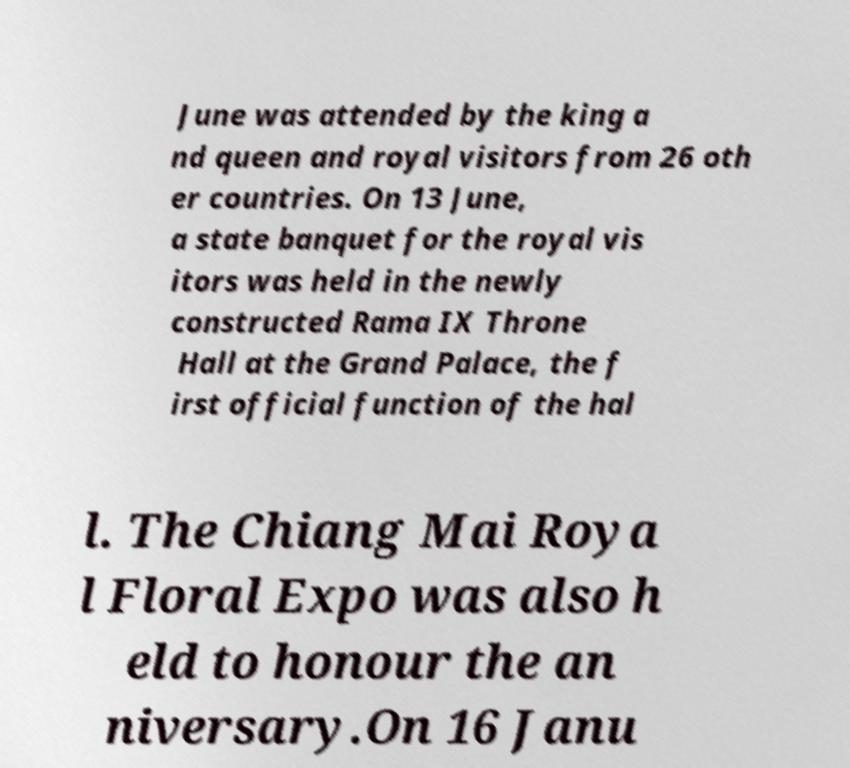Please identify and transcribe the text found in this image. June was attended by the king a nd queen and royal visitors from 26 oth er countries. On 13 June, a state banquet for the royal vis itors was held in the newly constructed Rama IX Throne Hall at the Grand Palace, the f irst official function of the hal l. The Chiang Mai Roya l Floral Expo was also h eld to honour the an niversary.On 16 Janu 